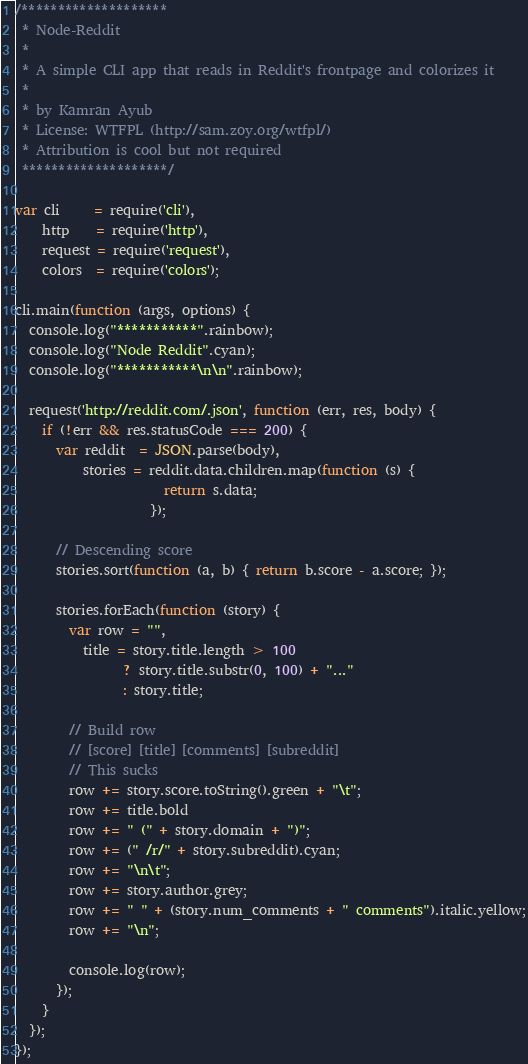<code> <loc_0><loc_0><loc_500><loc_500><_JavaScript_>/********************
 * Node-Reddit
 *
 * A simple CLI app that reads in Reddit's frontpage and colorizes it
 *
 * by Kamran Ayub
 * License: WTFPL (http://sam.zoy.org/wtfpl/)
 * Attribution is cool but not required
 ********************/

var cli     = require('cli'),
    http    = require('http'),
    request = require('request'),
    colors  = require('colors');

cli.main(function (args, options) {
  console.log("***********".rainbow);
  console.log("Node Reddit".cyan);
  console.log("***********\n\n".rainbow);

  request('http://reddit.com/.json', function (err, res, body) {
    if (!err && res.statusCode === 200) {
      var reddit  = JSON.parse(body),
          stories = reddit.data.children.map(function (s) { 
                      return s.data; 
                    });
      
      // Descending score
      stories.sort(function (a, b) { return b.score - a.score; });

      stories.forEach(function (story) {
        var row = "",
          title = story.title.length > 100
                ? story.title.substr(0, 100) + "..." 
                : story.title;

        // Build row
        // [score] [title] [comments] [subreddit]
        // This sucks
        row += story.score.toString().green + "\t";
        row += title.bold
        row += " (" + story.domain + ")";
        row += (" /r/" + story.subreddit).cyan;
        row += "\n\t";
        row += story.author.grey;     
        row += " " + (story.num_comments + " comments").italic.yellow;
        row += "\n";

        console.log(row);
      });
    }
  });
});</code> 